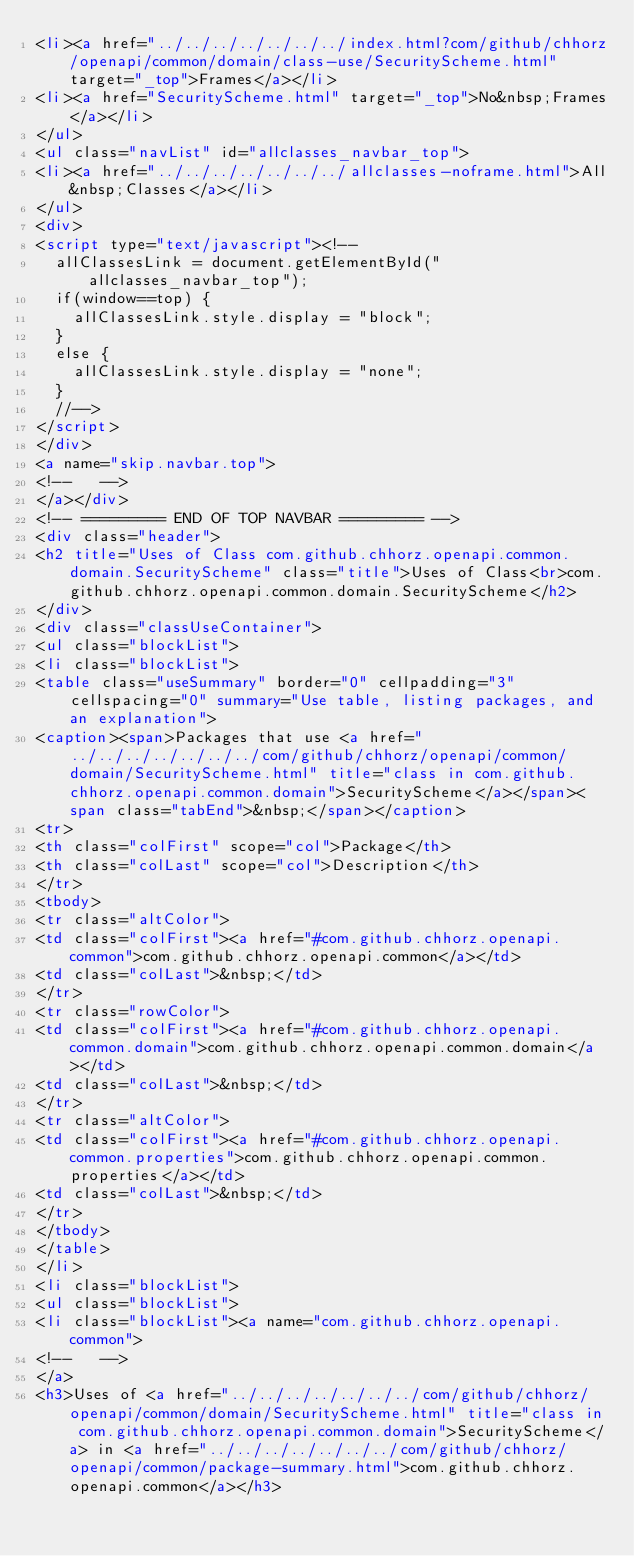Convert code to text. <code><loc_0><loc_0><loc_500><loc_500><_HTML_><li><a href="../../../../../../../index.html?com/github/chhorz/openapi/common/domain/class-use/SecurityScheme.html" target="_top">Frames</a></li>
<li><a href="SecurityScheme.html" target="_top">No&nbsp;Frames</a></li>
</ul>
<ul class="navList" id="allclasses_navbar_top">
<li><a href="../../../../../../../allclasses-noframe.html">All&nbsp;Classes</a></li>
</ul>
<div>
<script type="text/javascript"><!--
  allClassesLink = document.getElementById("allclasses_navbar_top");
  if(window==top) {
    allClassesLink.style.display = "block";
  }
  else {
    allClassesLink.style.display = "none";
  }
  //-->
</script>
</div>
<a name="skip.navbar.top">
<!--   -->
</a></div>
<!-- ========= END OF TOP NAVBAR ========= -->
<div class="header">
<h2 title="Uses of Class com.github.chhorz.openapi.common.domain.SecurityScheme" class="title">Uses of Class<br>com.github.chhorz.openapi.common.domain.SecurityScheme</h2>
</div>
<div class="classUseContainer">
<ul class="blockList">
<li class="blockList">
<table class="useSummary" border="0" cellpadding="3" cellspacing="0" summary="Use table, listing packages, and an explanation">
<caption><span>Packages that use <a href="../../../../../../../com/github/chhorz/openapi/common/domain/SecurityScheme.html" title="class in com.github.chhorz.openapi.common.domain">SecurityScheme</a></span><span class="tabEnd">&nbsp;</span></caption>
<tr>
<th class="colFirst" scope="col">Package</th>
<th class="colLast" scope="col">Description</th>
</tr>
<tbody>
<tr class="altColor">
<td class="colFirst"><a href="#com.github.chhorz.openapi.common">com.github.chhorz.openapi.common</a></td>
<td class="colLast">&nbsp;</td>
</tr>
<tr class="rowColor">
<td class="colFirst"><a href="#com.github.chhorz.openapi.common.domain">com.github.chhorz.openapi.common.domain</a></td>
<td class="colLast">&nbsp;</td>
</tr>
<tr class="altColor">
<td class="colFirst"><a href="#com.github.chhorz.openapi.common.properties">com.github.chhorz.openapi.common.properties</a></td>
<td class="colLast">&nbsp;</td>
</tr>
</tbody>
</table>
</li>
<li class="blockList">
<ul class="blockList">
<li class="blockList"><a name="com.github.chhorz.openapi.common">
<!--   -->
</a>
<h3>Uses of <a href="../../../../../../../com/github/chhorz/openapi/common/domain/SecurityScheme.html" title="class in com.github.chhorz.openapi.common.domain">SecurityScheme</a> in <a href="../../../../../../../com/github/chhorz/openapi/common/package-summary.html">com.github.chhorz.openapi.common</a></h3></code> 